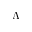Convert formula to latex. <formula><loc_0><loc_0><loc_500><loc_500>\Lambda</formula> 